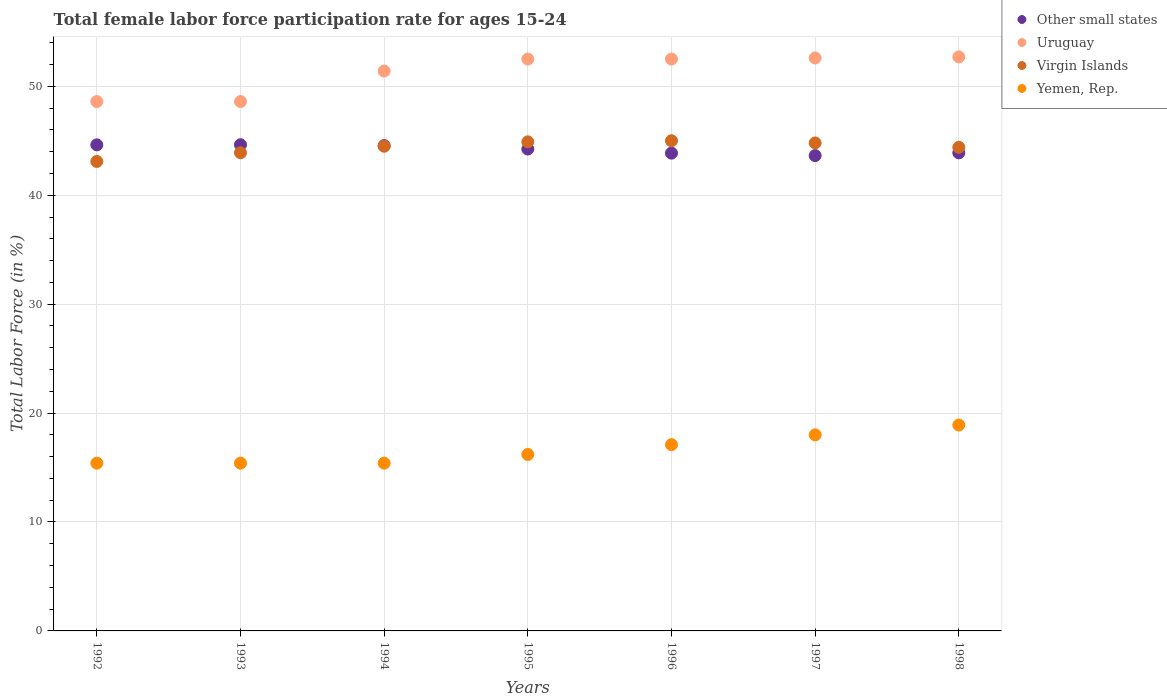How many different coloured dotlines are there?
Provide a short and direct response. 4. What is the female labor force participation rate in Uruguay in 1994?
Your answer should be very brief. 51.4. Across all years, what is the minimum female labor force participation rate in Yemen, Rep.?
Your answer should be compact. 15.4. What is the total female labor force participation rate in Uruguay in the graph?
Your answer should be very brief. 358.9. What is the difference between the female labor force participation rate in Other small states in 1995 and that in 1996?
Your answer should be very brief. 0.38. What is the difference between the female labor force participation rate in Yemen, Rep. in 1997 and the female labor force participation rate in Other small states in 1996?
Provide a succinct answer. -25.86. What is the average female labor force participation rate in Virgin Islands per year?
Provide a succinct answer. 44.37. In the year 1992, what is the difference between the female labor force participation rate in Yemen, Rep. and female labor force participation rate in Virgin Islands?
Make the answer very short. -27.7. What is the ratio of the female labor force participation rate in Uruguay in 1992 to that in 1994?
Provide a succinct answer. 0.95. Is the female labor force participation rate in Other small states in 1994 less than that in 1997?
Your answer should be compact. No. What is the difference between the highest and the second highest female labor force participation rate in Uruguay?
Ensure brevity in your answer.  0.1. What is the difference between the highest and the lowest female labor force participation rate in Yemen, Rep.?
Offer a very short reply. 3.5. How many dotlines are there?
Give a very brief answer. 4. Does the graph contain any zero values?
Your answer should be compact. No. Does the graph contain grids?
Make the answer very short. Yes. Where does the legend appear in the graph?
Offer a very short reply. Top right. What is the title of the graph?
Provide a succinct answer. Total female labor force participation rate for ages 15-24. Does "Honduras" appear as one of the legend labels in the graph?
Make the answer very short. No. What is the label or title of the Y-axis?
Keep it short and to the point. Total Labor Force (in %). What is the Total Labor Force (in %) of Other small states in 1992?
Provide a short and direct response. 44.62. What is the Total Labor Force (in %) in Uruguay in 1992?
Ensure brevity in your answer.  48.6. What is the Total Labor Force (in %) of Virgin Islands in 1992?
Your response must be concise. 43.1. What is the Total Labor Force (in %) of Yemen, Rep. in 1992?
Your response must be concise. 15.4. What is the Total Labor Force (in %) of Other small states in 1993?
Offer a terse response. 44.63. What is the Total Labor Force (in %) in Uruguay in 1993?
Your answer should be very brief. 48.6. What is the Total Labor Force (in %) of Virgin Islands in 1993?
Your answer should be very brief. 43.9. What is the Total Labor Force (in %) in Yemen, Rep. in 1993?
Provide a short and direct response. 15.4. What is the Total Labor Force (in %) of Other small states in 1994?
Your answer should be very brief. 44.55. What is the Total Labor Force (in %) in Uruguay in 1994?
Keep it short and to the point. 51.4. What is the Total Labor Force (in %) in Virgin Islands in 1994?
Provide a short and direct response. 44.5. What is the Total Labor Force (in %) of Yemen, Rep. in 1994?
Your answer should be very brief. 15.4. What is the Total Labor Force (in %) of Other small states in 1995?
Provide a succinct answer. 44.24. What is the Total Labor Force (in %) in Uruguay in 1995?
Provide a succinct answer. 52.5. What is the Total Labor Force (in %) in Virgin Islands in 1995?
Your answer should be very brief. 44.9. What is the Total Labor Force (in %) of Yemen, Rep. in 1995?
Give a very brief answer. 16.2. What is the Total Labor Force (in %) in Other small states in 1996?
Provide a succinct answer. 43.86. What is the Total Labor Force (in %) of Uruguay in 1996?
Provide a short and direct response. 52.5. What is the Total Labor Force (in %) in Virgin Islands in 1996?
Make the answer very short. 45. What is the Total Labor Force (in %) of Yemen, Rep. in 1996?
Your answer should be very brief. 17.1. What is the Total Labor Force (in %) in Other small states in 1997?
Make the answer very short. 43.64. What is the Total Labor Force (in %) of Uruguay in 1997?
Offer a terse response. 52.6. What is the Total Labor Force (in %) in Virgin Islands in 1997?
Make the answer very short. 44.8. What is the Total Labor Force (in %) in Yemen, Rep. in 1997?
Your answer should be compact. 18. What is the Total Labor Force (in %) of Other small states in 1998?
Your response must be concise. 43.89. What is the Total Labor Force (in %) in Uruguay in 1998?
Keep it short and to the point. 52.7. What is the Total Labor Force (in %) of Virgin Islands in 1998?
Your answer should be compact. 44.4. What is the Total Labor Force (in %) of Yemen, Rep. in 1998?
Your answer should be very brief. 18.9. Across all years, what is the maximum Total Labor Force (in %) of Other small states?
Provide a short and direct response. 44.63. Across all years, what is the maximum Total Labor Force (in %) in Uruguay?
Keep it short and to the point. 52.7. Across all years, what is the maximum Total Labor Force (in %) of Yemen, Rep.?
Offer a very short reply. 18.9. Across all years, what is the minimum Total Labor Force (in %) of Other small states?
Keep it short and to the point. 43.64. Across all years, what is the minimum Total Labor Force (in %) in Uruguay?
Keep it short and to the point. 48.6. Across all years, what is the minimum Total Labor Force (in %) in Virgin Islands?
Your answer should be compact. 43.1. Across all years, what is the minimum Total Labor Force (in %) in Yemen, Rep.?
Your response must be concise. 15.4. What is the total Total Labor Force (in %) in Other small states in the graph?
Your answer should be compact. 309.44. What is the total Total Labor Force (in %) in Uruguay in the graph?
Your answer should be compact. 358.9. What is the total Total Labor Force (in %) of Virgin Islands in the graph?
Offer a terse response. 310.6. What is the total Total Labor Force (in %) in Yemen, Rep. in the graph?
Your answer should be compact. 116.4. What is the difference between the Total Labor Force (in %) of Other small states in 1992 and that in 1993?
Your answer should be compact. -0.01. What is the difference between the Total Labor Force (in %) of Uruguay in 1992 and that in 1993?
Keep it short and to the point. 0. What is the difference between the Total Labor Force (in %) of Virgin Islands in 1992 and that in 1993?
Offer a terse response. -0.8. What is the difference between the Total Labor Force (in %) in Other small states in 1992 and that in 1994?
Keep it short and to the point. 0.07. What is the difference between the Total Labor Force (in %) of Uruguay in 1992 and that in 1994?
Your answer should be very brief. -2.8. What is the difference between the Total Labor Force (in %) in Virgin Islands in 1992 and that in 1994?
Provide a succinct answer. -1.4. What is the difference between the Total Labor Force (in %) of Other small states in 1992 and that in 1995?
Keep it short and to the point. 0.39. What is the difference between the Total Labor Force (in %) in Uruguay in 1992 and that in 1995?
Your response must be concise. -3.9. What is the difference between the Total Labor Force (in %) of Other small states in 1992 and that in 1996?
Provide a succinct answer. 0.76. What is the difference between the Total Labor Force (in %) in Uruguay in 1992 and that in 1996?
Ensure brevity in your answer.  -3.9. What is the difference between the Total Labor Force (in %) in Virgin Islands in 1992 and that in 1996?
Ensure brevity in your answer.  -1.9. What is the difference between the Total Labor Force (in %) in Yemen, Rep. in 1992 and that in 1996?
Offer a terse response. -1.7. What is the difference between the Total Labor Force (in %) of Virgin Islands in 1992 and that in 1997?
Your response must be concise. -1.7. What is the difference between the Total Labor Force (in %) in Yemen, Rep. in 1992 and that in 1997?
Offer a terse response. -2.6. What is the difference between the Total Labor Force (in %) in Other small states in 1992 and that in 1998?
Offer a terse response. 0.73. What is the difference between the Total Labor Force (in %) of Virgin Islands in 1992 and that in 1998?
Your answer should be compact. -1.3. What is the difference between the Total Labor Force (in %) of Other small states in 1993 and that in 1994?
Provide a short and direct response. 0.08. What is the difference between the Total Labor Force (in %) of Uruguay in 1993 and that in 1994?
Your response must be concise. -2.8. What is the difference between the Total Labor Force (in %) in Yemen, Rep. in 1993 and that in 1994?
Offer a very short reply. 0. What is the difference between the Total Labor Force (in %) of Other small states in 1993 and that in 1995?
Give a very brief answer. 0.4. What is the difference between the Total Labor Force (in %) in Virgin Islands in 1993 and that in 1995?
Offer a very short reply. -1. What is the difference between the Total Labor Force (in %) of Other small states in 1993 and that in 1996?
Provide a succinct answer. 0.77. What is the difference between the Total Labor Force (in %) of Other small states in 1993 and that in 1997?
Offer a very short reply. 1. What is the difference between the Total Labor Force (in %) in Uruguay in 1993 and that in 1997?
Provide a short and direct response. -4. What is the difference between the Total Labor Force (in %) of Virgin Islands in 1993 and that in 1997?
Ensure brevity in your answer.  -0.9. What is the difference between the Total Labor Force (in %) of Yemen, Rep. in 1993 and that in 1997?
Provide a succinct answer. -2.6. What is the difference between the Total Labor Force (in %) of Other small states in 1993 and that in 1998?
Keep it short and to the point. 0.74. What is the difference between the Total Labor Force (in %) in Virgin Islands in 1993 and that in 1998?
Keep it short and to the point. -0.5. What is the difference between the Total Labor Force (in %) of Other small states in 1994 and that in 1995?
Provide a succinct answer. 0.32. What is the difference between the Total Labor Force (in %) in Uruguay in 1994 and that in 1995?
Provide a short and direct response. -1.1. What is the difference between the Total Labor Force (in %) of Yemen, Rep. in 1994 and that in 1995?
Your answer should be compact. -0.8. What is the difference between the Total Labor Force (in %) of Other small states in 1994 and that in 1996?
Offer a terse response. 0.69. What is the difference between the Total Labor Force (in %) in Virgin Islands in 1994 and that in 1996?
Offer a terse response. -0.5. What is the difference between the Total Labor Force (in %) in Yemen, Rep. in 1994 and that in 1996?
Make the answer very short. -1.7. What is the difference between the Total Labor Force (in %) of Other small states in 1994 and that in 1997?
Your response must be concise. 0.92. What is the difference between the Total Labor Force (in %) in Virgin Islands in 1994 and that in 1997?
Keep it short and to the point. -0.3. What is the difference between the Total Labor Force (in %) in Other small states in 1994 and that in 1998?
Offer a terse response. 0.66. What is the difference between the Total Labor Force (in %) in Virgin Islands in 1994 and that in 1998?
Provide a succinct answer. 0.1. What is the difference between the Total Labor Force (in %) in Yemen, Rep. in 1994 and that in 1998?
Keep it short and to the point. -3.5. What is the difference between the Total Labor Force (in %) of Other small states in 1995 and that in 1996?
Provide a short and direct response. 0.38. What is the difference between the Total Labor Force (in %) of Other small states in 1995 and that in 1997?
Offer a very short reply. 0.6. What is the difference between the Total Labor Force (in %) of Uruguay in 1995 and that in 1997?
Offer a terse response. -0.1. What is the difference between the Total Labor Force (in %) of Virgin Islands in 1995 and that in 1997?
Ensure brevity in your answer.  0.1. What is the difference between the Total Labor Force (in %) of Other small states in 1995 and that in 1998?
Your answer should be very brief. 0.35. What is the difference between the Total Labor Force (in %) of Uruguay in 1995 and that in 1998?
Provide a short and direct response. -0.2. What is the difference between the Total Labor Force (in %) of Virgin Islands in 1995 and that in 1998?
Keep it short and to the point. 0.5. What is the difference between the Total Labor Force (in %) of Yemen, Rep. in 1995 and that in 1998?
Your answer should be very brief. -2.7. What is the difference between the Total Labor Force (in %) in Other small states in 1996 and that in 1997?
Keep it short and to the point. 0.23. What is the difference between the Total Labor Force (in %) in Yemen, Rep. in 1996 and that in 1997?
Your answer should be compact. -0.9. What is the difference between the Total Labor Force (in %) of Other small states in 1996 and that in 1998?
Keep it short and to the point. -0.03. What is the difference between the Total Labor Force (in %) of Uruguay in 1996 and that in 1998?
Give a very brief answer. -0.2. What is the difference between the Total Labor Force (in %) in Virgin Islands in 1996 and that in 1998?
Keep it short and to the point. 0.6. What is the difference between the Total Labor Force (in %) in Yemen, Rep. in 1996 and that in 1998?
Ensure brevity in your answer.  -1.8. What is the difference between the Total Labor Force (in %) of Other small states in 1997 and that in 1998?
Offer a very short reply. -0.25. What is the difference between the Total Labor Force (in %) in Uruguay in 1997 and that in 1998?
Offer a terse response. -0.1. What is the difference between the Total Labor Force (in %) in Yemen, Rep. in 1997 and that in 1998?
Your answer should be very brief. -0.9. What is the difference between the Total Labor Force (in %) in Other small states in 1992 and the Total Labor Force (in %) in Uruguay in 1993?
Your answer should be very brief. -3.98. What is the difference between the Total Labor Force (in %) in Other small states in 1992 and the Total Labor Force (in %) in Virgin Islands in 1993?
Provide a short and direct response. 0.72. What is the difference between the Total Labor Force (in %) of Other small states in 1992 and the Total Labor Force (in %) of Yemen, Rep. in 1993?
Offer a very short reply. 29.22. What is the difference between the Total Labor Force (in %) of Uruguay in 1992 and the Total Labor Force (in %) of Yemen, Rep. in 1993?
Ensure brevity in your answer.  33.2. What is the difference between the Total Labor Force (in %) of Virgin Islands in 1992 and the Total Labor Force (in %) of Yemen, Rep. in 1993?
Your answer should be compact. 27.7. What is the difference between the Total Labor Force (in %) in Other small states in 1992 and the Total Labor Force (in %) in Uruguay in 1994?
Your response must be concise. -6.78. What is the difference between the Total Labor Force (in %) of Other small states in 1992 and the Total Labor Force (in %) of Virgin Islands in 1994?
Keep it short and to the point. 0.12. What is the difference between the Total Labor Force (in %) of Other small states in 1992 and the Total Labor Force (in %) of Yemen, Rep. in 1994?
Offer a terse response. 29.22. What is the difference between the Total Labor Force (in %) of Uruguay in 1992 and the Total Labor Force (in %) of Yemen, Rep. in 1994?
Provide a short and direct response. 33.2. What is the difference between the Total Labor Force (in %) in Virgin Islands in 1992 and the Total Labor Force (in %) in Yemen, Rep. in 1994?
Keep it short and to the point. 27.7. What is the difference between the Total Labor Force (in %) of Other small states in 1992 and the Total Labor Force (in %) of Uruguay in 1995?
Provide a succinct answer. -7.88. What is the difference between the Total Labor Force (in %) of Other small states in 1992 and the Total Labor Force (in %) of Virgin Islands in 1995?
Make the answer very short. -0.28. What is the difference between the Total Labor Force (in %) in Other small states in 1992 and the Total Labor Force (in %) in Yemen, Rep. in 1995?
Your answer should be compact. 28.42. What is the difference between the Total Labor Force (in %) of Uruguay in 1992 and the Total Labor Force (in %) of Virgin Islands in 1995?
Provide a short and direct response. 3.7. What is the difference between the Total Labor Force (in %) of Uruguay in 1992 and the Total Labor Force (in %) of Yemen, Rep. in 1995?
Your answer should be very brief. 32.4. What is the difference between the Total Labor Force (in %) in Virgin Islands in 1992 and the Total Labor Force (in %) in Yemen, Rep. in 1995?
Offer a terse response. 26.9. What is the difference between the Total Labor Force (in %) in Other small states in 1992 and the Total Labor Force (in %) in Uruguay in 1996?
Ensure brevity in your answer.  -7.88. What is the difference between the Total Labor Force (in %) in Other small states in 1992 and the Total Labor Force (in %) in Virgin Islands in 1996?
Your answer should be compact. -0.38. What is the difference between the Total Labor Force (in %) of Other small states in 1992 and the Total Labor Force (in %) of Yemen, Rep. in 1996?
Make the answer very short. 27.52. What is the difference between the Total Labor Force (in %) in Uruguay in 1992 and the Total Labor Force (in %) in Yemen, Rep. in 1996?
Offer a very short reply. 31.5. What is the difference between the Total Labor Force (in %) of Virgin Islands in 1992 and the Total Labor Force (in %) of Yemen, Rep. in 1996?
Your answer should be compact. 26. What is the difference between the Total Labor Force (in %) of Other small states in 1992 and the Total Labor Force (in %) of Uruguay in 1997?
Offer a terse response. -7.98. What is the difference between the Total Labor Force (in %) of Other small states in 1992 and the Total Labor Force (in %) of Virgin Islands in 1997?
Provide a succinct answer. -0.18. What is the difference between the Total Labor Force (in %) of Other small states in 1992 and the Total Labor Force (in %) of Yemen, Rep. in 1997?
Make the answer very short. 26.62. What is the difference between the Total Labor Force (in %) of Uruguay in 1992 and the Total Labor Force (in %) of Yemen, Rep. in 1997?
Make the answer very short. 30.6. What is the difference between the Total Labor Force (in %) in Virgin Islands in 1992 and the Total Labor Force (in %) in Yemen, Rep. in 1997?
Your answer should be very brief. 25.1. What is the difference between the Total Labor Force (in %) in Other small states in 1992 and the Total Labor Force (in %) in Uruguay in 1998?
Make the answer very short. -8.08. What is the difference between the Total Labor Force (in %) of Other small states in 1992 and the Total Labor Force (in %) of Virgin Islands in 1998?
Make the answer very short. 0.22. What is the difference between the Total Labor Force (in %) in Other small states in 1992 and the Total Labor Force (in %) in Yemen, Rep. in 1998?
Make the answer very short. 25.72. What is the difference between the Total Labor Force (in %) of Uruguay in 1992 and the Total Labor Force (in %) of Yemen, Rep. in 1998?
Give a very brief answer. 29.7. What is the difference between the Total Labor Force (in %) of Virgin Islands in 1992 and the Total Labor Force (in %) of Yemen, Rep. in 1998?
Provide a short and direct response. 24.2. What is the difference between the Total Labor Force (in %) of Other small states in 1993 and the Total Labor Force (in %) of Uruguay in 1994?
Your answer should be compact. -6.77. What is the difference between the Total Labor Force (in %) of Other small states in 1993 and the Total Labor Force (in %) of Virgin Islands in 1994?
Keep it short and to the point. 0.13. What is the difference between the Total Labor Force (in %) in Other small states in 1993 and the Total Labor Force (in %) in Yemen, Rep. in 1994?
Provide a short and direct response. 29.23. What is the difference between the Total Labor Force (in %) of Uruguay in 1993 and the Total Labor Force (in %) of Yemen, Rep. in 1994?
Keep it short and to the point. 33.2. What is the difference between the Total Labor Force (in %) of Virgin Islands in 1993 and the Total Labor Force (in %) of Yemen, Rep. in 1994?
Your answer should be compact. 28.5. What is the difference between the Total Labor Force (in %) of Other small states in 1993 and the Total Labor Force (in %) of Uruguay in 1995?
Make the answer very short. -7.87. What is the difference between the Total Labor Force (in %) of Other small states in 1993 and the Total Labor Force (in %) of Virgin Islands in 1995?
Ensure brevity in your answer.  -0.27. What is the difference between the Total Labor Force (in %) of Other small states in 1993 and the Total Labor Force (in %) of Yemen, Rep. in 1995?
Ensure brevity in your answer.  28.43. What is the difference between the Total Labor Force (in %) of Uruguay in 1993 and the Total Labor Force (in %) of Virgin Islands in 1995?
Your answer should be very brief. 3.7. What is the difference between the Total Labor Force (in %) in Uruguay in 1993 and the Total Labor Force (in %) in Yemen, Rep. in 1995?
Provide a short and direct response. 32.4. What is the difference between the Total Labor Force (in %) in Virgin Islands in 1993 and the Total Labor Force (in %) in Yemen, Rep. in 1995?
Offer a terse response. 27.7. What is the difference between the Total Labor Force (in %) of Other small states in 1993 and the Total Labor Force (in %) of Uruguay in 1996?
Your answer should be compact. -7.87. What is the difference between the Total Labor Force (in %) in Other small states in 1993 and the Total Labor Force (in %) in Virgin Islands in 1996?
Your response must be concise. -0.37. What is the difference between the Total Labor Force (in %) in Other small states in 1993 and the Total Labor Force (in %) in Yemen, Rep. in 1996?
Provide a short and direct response. 27.53. What is the difference between the Total Labor Force (in %) in Uruguay in 1993 and the Total Labor Force (in %) in Yemen, Rep. in 1996?
Offer a terse response. 31.5. What is the difference between the Total Labor Force (in %) of Virgin Islands in 1993 and the Total Labor Force (in %) of Yemen, Rep. in 1996?
Give a very brief answer. 26.8. What is the difference between the Total Labor Force (in %) in Other small states in 1993 and the Total Labor Force (in %) in Uruguay in 1997?
Provide a succinct answer. -7.97. What is the difference between the Total Labor Force (in %) of Other small states in 1993 and the Total Labor Force (in %) of Virgin Islands in 1997?
Provide a succinct answer. -0.17. What is the difference between the Total Labor Force (in %) in Other small states in 1993 and the Total Labor Force (in %) in Yemen, Rep. in 1997?
Give a very brief answer. 26.63. What is the difference between the Total Labor Force (in %) of Uruguay in 1993 and the Total Labor Force (in %) of Yemen, Rep. in 1997?
Provide a succinct answer. 30.6. What is the difference between the Total Labor Force (in %) in Virgin Islands in 1993 and the Total Labor Force (in %) in Yemen, Rep. in 1997?
Your response must be concise. 25.9. What is the difference between the Total Labor Force (in %) in Other small states in 1993 and the Total Labor Force (in %) in Uruguay in 1998?
Provide a succinct answer. -8.07. What is the difference between the Total Labor Force (in %) of Other small states in 1993 and the Total Labor Force (in %) of Virgin Islands in 1998?
Provide a short and direct response. 0.23. What is the difference between the Total Labor Force (in %) in Other small states in 1993 and the Total Labor Force (in %) in Yemen, Rep. in 1998?
Offer a very short reply. 25.73. What is the difference between the Total Labor Force (in %) in Uruguay in 1993 and the Total Labor Force (in %) in Yemen, Rep. in 1998?
Your response must be concise. 29.7. What is the difference between the Total Labor Force (in %) in Other small states in 1994 and the Total Labor Force (in %) in Uruguay in 1995?
Your response must be concise. -7.95. What is the difference between the Total Labor Force (in %) of Other small states in 1994 and the Total Labor Force (in %) of Virgin Islands in 1995?
Provide a short and direct response. -0.35. What is the difference between the Total Labor Force (in %) of Other small states in 1994 and the Total Labor Force (in %) of Yemen, Rep. in 1995?
Offer a very short reply. 28.35. What is the difference between the Total Labor Force (in %) of Uruguay in 1994 and the Total Labor Force (in %) of Yemen, Rep. in 1995?
Your response must be concise. 35.2. What is the difference between the Total Labor Force (in %) of Virgin Islands in 1994 and the Total Labor Force (in %) of Yemen, Rep. in 1995?
Offer a very short reply. 28.3. What is the difference between the Total Labor Force (in %) of Other small states in 1994 and the Total Labor Force (in %) of Uruguay in 1996?
Your response must be concise. -7.95. What is the difference between the Total Labor Force (in %) of Other small states in 1994 and the Total Labor Force (in %) of Virgin Islands in 1996?
Your response must be concise. -0.45. What is the difference between the Total Labor Force (in %) of Other small states in 1994 and the Total Labor Force (in %) of Yemen, Rep. in 1996?
Make the answer very short. 27.45. What is the difference between the Total Labor Force (in %) in Uruguay in 1994 and the Total Labor Force (in %) in Virgin Islands in 1996?
Make the answer very short. 6.4. What is the difference between the Total Labor Force (in %) in Uruguay in 1994 and the Total Labor Force (in %) in Yemen, Rep. in 1996?
Give a very brief answer. 34.3. What is the difference between the Total Labor Force (in %) of Virgin Islands in 1994 and the Total Labor Force (in %) of Yemen, Rep. in 1996?
Your response must be concise. 27.4. What is the difference between the Total Labor Force (in %) of Other small states in 1994 and the Total Labor Force (in %) of Uruguay in 1997?
Offer a terse response. -8.05. What is the difference between the Total Labor Force (in %) of Other small states in 1994 and the Total Labor Force (in %) of Virgin Islands in 1997?
Your answer should be compact. -0.25. What is the difference between the Total Labor Force (in %) of Other small states in 1994 and the Total Labor Force (in %) of Yemen, Rep. in 1997?
Your response must be concise. 26.55. What is the difference between the Total Labor Force (in %) in Uruguay in 1994 and the Total Labor Force (in %) in Yemen, Rep. in 1997?
Your response must be concise. 33.4. What is the difference between the Total Labor Force (in %) in Other small states in 1994 and the Total Labor Force (in %) in Uruguay in 1998?
Your response must be concise. -8.15. What is the difference between the Total Labor Force (in %) in Other small states in 1994 and the Total Labor Force (in %) in Virgin Islands in 1998?
Your response must be concise. 0.15. What is the difference between the Total Labor Force (in %) of Other small states in 1994 and the Total Labor Force (in %) of Yemen, Rep. in 1998?
Give a very brief answer. 25.65. What is the difference between the Total Labor Force (in %) in Uruguay in 1994 and the Total Labor Force (in %) in Virgin Islands in 1998?
Give a very brief answer. 7. What is the difference between the Total Labor Force (in %) of Uruguay in 1994 and the Total Labor Force (in %) of Yemen, Rep. in 1998?
Your answer should be compact. 32.5. What is the difference between the Total Labor Force (in %) in Virgin Islands in 1994 and the Total Labor Force (in %) in Yemen, Rep. in 1998?
Your response must be concise. 25.6. What is the difference between the Total Labor Force (in %) of Other small states in 1995 and the Total Labor Force (in %) of Uruguay in 1996?
Ensure brevity in your answer.  -8.26. What is the difference between the Total Labor Force (in %) in Other small states in 1995 and the Total Labor Force (in %) in Virgin Islands in 1996?
Ensure brevity in your answer.  -0.76. What is the difference between the Total Labor Force (in %) of Other small states in 1995 and the Total Labor Force (in %) of Yemen, Rep. in 1996?
Make the answer very short. 27.14. What is the difference between the Total Labor Force (in %) in Uruguay in 1995 and the Total Labor Force (in %) in Virgin Islands in 1996?
Keep it short and to the point. 7.5. What is the difference between the Total Labor Force (in %) of Uruguay in 1995 and the Total Labor Force (in %) of Yemen, Rep. in 1996?
Keep it short and to the point. 35.4. What is the difference between the Total Labor Force (in %) in Virgin Islands in 1995 and the Total Labor Force (in %) in Yemen, Rep. in 1996?
Your answer should be very brief. 27.8. What is the difference between the Total Labor Force (in %) of Other small states in 1995 and the Total Labor Force (in %) of Uruguay in 1997?
Your answer should be very brief. -8.36. What is the difference between the Total Labor Force (in %) of Other small states in 1995 and the Total Labor Force (in %) of Virgin Islands in 1997?
Provide a short and direct response. -0.56. What is the difference between the Total Labor Force (in %) of Other small states in 1995 and the Total Labor Force (in %) of Yemen, Rep. in 1997?
Your answer should be very brief. 26.24. What is the difference between the Total Labor Force (in %) in Uruguay in 1995 and the Total Labor Force (in %) in Virgin Islands in 1997?
Your answer should be compact. 7.7. What is the difference between the Total Labor Force (in %) of Uruguay in 1995 and the Total Labor Force (in %) of Yemen, Rep. in 1997?
Ensure brevity in your answer.  34.5. What is the difference between the Total Labor Force (in %) in Virgin Islands in 1995 and the Total Labor Force (in %) in Yemen, Rep. in 1997?
Your answer should be very brief. 26.9. What is the difference between the Total Labor Force (in %) in Other small states in 1995 and the Total Labor Force (in %) in Uruguay in 1998?
Provide a short and direct response. -8.46. What is the difference between the Total Labor Force (in %) in Other small states in 1995 and the Total Labor Force (in %) in Virgin Islands in 1998?
Make the answer very short. -0.16. What is the difference between the Total Labor Force (in %) in Other small states in 1995 and the Total Labor Force (in %) in Yemen, Rep. in 1998?
Keep it short and to the point. 25.34. What is the difference between the Total Labor Force (in %) of Uruguay in 1995 and the Total Labor Force (in %) of Virgin Islands in 1998?
Offer a very short reply. 8.1. What is the difference between the Total Labor Force (in %) in Uruguay in 1995 and the Total Labor Force (in %) in Yemen, Rep. in 1998?
Give a very brief answer. 33.6. What is the difference between the Total Labor Force (in %) in Virgin Islands in 1995 and the Total Labor Force (in %) in Yemen, Rep. in 1998?
Your answer should be very brief. 26. What is the difference between the Total Labor Force (in %) in Other small states in 1996 and the Total Labor Force (in %) in Uruguay in 1997?
Ensure brevity in your answer.  -8.74. What is the difference between the Total Labor Force (in %) in Other small states in 1996 and the Total Labor Force (in %) in Virgin Islands in 1997?
Give a very brief answer. -0.94. What is the difference between the Total Labor Force (in %) in Other small states in 1996 and the Total Labor Force (in %) in Yemen, Rep. in 1997?
Offer a very short reply. 25.86. What is the difference between the Total Labor Force (in %) in Uruguay in 1996 and the Total Labor Force (in %) in Virgin Islands in 1997?
Keep it short and to the point. 7.7. What is the difference between the Total Labor Force (in %) of Uruguay in 1996 and the Total Labor Force (in %) of Yemen, Rep. in 1997?
Ensure brevity in your answer.  34.5. What is the difference between the Total Labor Force (in %) of Virgin Islands in 1996 and the Total Labor Force (in %) of Yemen, Rep. in 1997?
Your response must be concise. 27. What is the difference between the Total Labor Force (in %) of Other small states in 1996 and the Total Labor Force (in %) of Uruguay in 1998?
Offer a terse response. -8.84. What is the difference between the Total Labor Force (in %) in Other small states in 1996 and the Total Labor Force (in %) in Virgin Islands in 1998?
Keep it short and to the point. -0.54. What is the difference between the Total Labor Force (in %) of Other small states in 1996 and the Total Labor Force (in %) of Yemen, Rep. in 1998?
Give a very brief answer. 24.96. What is the difference between the Total Labor Force (in %) in Uruguay in 1996 and the Total Labor Force (in %) in Virgin Islands in 1998?
Ensure brevity in your answer.  8.1. What is the difference between the Total Labor Force (in %) in Uruguay in 1996 and the Total Labor Force (in %) in Yemen, Rep. in 1998?
Offer a very short reply. 33.6. What is the difference between the Total Labor Force (in %) of Virgin Islands in 1996 and the Total Labor Force (in %) of Yemen, Rep. in 1998?
Offer a terse response. 26.1. What is the difference between the Total Labor Force (in %) in Other small states in 1997 and the Total Labor Force (in %) in Uruguay in 1998?
Keep it short and to the point. -9.06. What is the difference between the Total Labor Force (in %) in Other small states in 1997 and the Total Labor Force (in %) in Virgin Islands in 1998?
Keep it short and to the point. -0.76. What is the difference between the Total Labor Force (in %) in Other small states in 1997 and the Total Labor Force (in %) in Yemen, Rep. in 1998?
Your response must be concise. 24.74. What is the difference between the Total Labor Force (in %) of Uruguay in 1997 and the Total Labor Force (in %) of Yemen, Rep. in 1998?
Keep it short and to the point. 33.7. What is the difference between the Total Labor Force (in %) of Virgin Islands in 1997 and the Total Labor Force (in %) of Yemen, Rep. in 1998?
Keep it short and to the point. 25.9. What is the average Total Labor Force (in %) of Other small states per year?
Your response must be concise. 44.21. What is the average Total Labor Force (in %) of Uruguay per year?
Your answer should be very brief. 51.27. What is the average Total Labor Force (in %) of Virgin Islands per year?
Offer a terse response. 44.37. What is the average Total Labor Force (in %) of Yemen, Rep. per year?
Make the answer very short. 16.63. In the year 1992, what is the difference between the Total Labor Force (in %) of Other small states and Total Labor Force (in %) of Uruguay?
Your response must be concise. -3.98. In the year 1992, what is the difference between the Total Labor Force (in %) of Other small states and Total Labor Force (in %) of Virgin Islands?
Offer a very short reply. 1.52. In the year 1992, what is the difference between the Total Labor Force (in %) in Other small states and Total Labor Force (in %) in Yemen, Rep.?
Offer a very short reply. 29.22. In the year 1992, what is the difference between the Total Labor Force (in %) of Uruguay and Total Labor Force (in %) of Virgin Islands?
Your answer should be compact. 5.5. In the year 1992, what is the difference between the Total Labor Force (in %) of Uruguay and Total Labor Force (in %) of Yemen, Rep.?
Your response must be concise. 33.2. In the year 1992, what is the difference between the Total Labor Force (in %) of Virgin Islands and Total Labor Force (in %) of Yemen, Rep.?
Offer a very short reply. 27.7. In the year 1993, what is the difference between the Total Labor Force (in %) of Other small states and Total Labor Force (in %) of Uruguay?
Offer a terse response. -3.97. In the year 1993, what is the difference between the Total Labor Force (in %) of Other small states and Total Labor Force (in %) of Virgin Islands?
Provide a short and direct response. 0.73. In the year 1993, what is the difference between the Total Labor Force (in %) in Other small states and Total Labor Force (in %) in Yemen, Rep.?
Offer a terse response. 29.23. In the year 1993, what is the difference between the Total Labor Force (in %) in Uruguay and Total Labor Force (in %) in Yemen, Rep.?
Your answer should be compact. 33.2. In the year 1994, what is the difference between the Total Labor Force (in %) in Other small states and Total Labor Force (in %) in Uruguay?
Give a very brief answer. -6.85. In the year 1994, what is the difference between the Total Labor Force (in %) of Other small states and Total Labor Force (in %) of Virgin Islands?
Offer a terse response. 0.05. In the year 1994, what is the difference between the Total Labor Force (in %) in Other small states and Total Labor Force (in %) in Yemen, Rep.?
Your response must be concise. 29.15. In the year 1994, what is the difference between the Total Labor Force (in %) of Virgin Islands and Total Labor Force (in %) of Yemen, Rep.?
Offer a very short reply. 29.1. In the year 1995, what is the difference between the Total Labor Force (in %) of Other small states and Total Labor Force (in %) of Uruguay?
Make the answer very short. -8.26. In the year 1995, what is the difference between the Total Labor Force (in %) of Other small states and Total Labor Force (in %) of Virgin Islands?
Your answer should be compact. -0.66. In the year 1995, what is the difference between the Total Labor Force (in %) of Other small states and Total Labor Force (in %) of Yemen, Rep.?
Offer a terse response. 28.04. In the year 1995, what is the difference between the Total Labor Force (in %) in Uruguay and Total Labor Force (in %) in Virgin Islands?
Your answer should be very brief. 7.6. In the year 1995, what is the difference between the Total Labor Force (in %) of Uruguay and Total Labor Force (in %) of Yemen, Rep.?
Make the answer very short. 36.3. In the year 1995, what is the difference between the Total Labor Force (in %) in Virgin Islands and Total Labor Force (in %) in Yemen, Rep.?
Provide a short and direct response. 28.7. In the year 1996, what is the difference between the Total Labor Force (in %) in Other small states and Total Labor Force (in %) in Uruguay?
Ensure brevity in your answer.  -8.64. In the year 1996, what is the difference between the Total Labor Force (in %) in Other small states and Total Labor Force (in %) in Virgin Islands?
Make the answer very short. -1.14. In the year 1996, what is the difference between the Total Labor Force (in %) in Other small states and Total Labor Force (in %) in Yemen, Rep.?
Your answer should be compact. 26.76. In the year 1996, what is the difference between the Total Labor Force (in %) of Uruguay and Total Labor Force (in %) of Virgin Islands?
Provide a short and direct response. 7.5. In the year 1996, what is the difference between the Total Labor Force (in %) in Uruguay and Total Labor Force (in %) in Yemen, Rep.?
Your response must be concise. 35.4. In the year 1996, what is the difference between the Total Labor Force (in %) in Virgin Islands and Total Labor Force (in %) in Yemen, Rep.?
Ensure brevity in your answer.  27.9. In the year 1997, what is the difference between the Total Labor Force (in %) in Other small states and Total Labor Force (in %) in Uruguay?
Provide a short and direct response. -8.96. In the year 1997, what is the difference between the Total Labor Force (in %) in Other small states and Total Labor Force (in %) in Virgin Islands?
Your answer should be compact. -1.16. In the year 1997, what is the difference between the Total Labor Force (in %) of Other small states and Total Labor Force (in %) of Yemen, Rep.?
Your answer should be compact. 25.64. In the year 1997, what is the difference between the Total Labor Force (in %) of Uruguay and Total Labor Force (in %) of Yemen, Rep.?
Provide a succinct answer. 34.6. In the year 1997, what is the difference between the Total Labor Force (in %) in Virgin Islands and Total Labor Force (in %) in Yemen, Rep.?
Make the answer very short. 26.8. In the year 1998, what is the difference between the Total Labor Force (in %) in Other small states and Total Labor Force (in %) in Uruguay?
Ensure brevity in your answer.  -8.81. In the year 1998, what is the difference between the Total Labor Force (in %) in Other small states and Total Labor Force (in %) in Virgin Islands?
Provide a short and direct response. -0.51. In the year 1998, what is the difference between the Total Labor Force (in %) of Other small states and Total Labor Force (in %) of Yemen, Rep.?
Ensure brevity in your answer.  24.99. In the year 1998, what is the difference between the Total Labor Force (in %) in Uruguay and Total Labor Force (in %) in Yemen, Rep.?
Ensure brevity in your answer.  33.8. In the year 1998, what is the difference between the Total Labor Force (in %) in Virgin Islands and Total Labor Force (in %) in Yemen, Rep.?
Ensure brevity in your answer.  25.5. What is the ratio of the Total Labor Force (in %) of Other small states in 1992 to that in 1993?
Offer a terse response. 1. What is the ratio of the Total Labor Force (in %) of Uruguay in 1992 to that in 1993?
Provide a short and direct response. 1. What is the ratio of the Total Labor Force (in %) of Virgin Islands in 1992 to that in 1993?
Offer a terse response. 0.98. What is the ratio of the Total Labor Force (in %) in Other small states in 1992 to that in 1994?
Give a very brief answer. 1. What is the ratio of the Total Labor Force (in %) of Uruguay in 1992 to that in 1994?
Your answer should be compact. 0.95. What is the ratio of the Total Labor Force (in %) in Virgin Islands in 1992 to that in 1994?
Offer a terse response. 0.97. What is the ratio of the Total Labor Force (in %) in Yemen, Rep. in 1992 to that in 1994?
Offer a terse response. 1. What is the ratio of the Total Labor Force (in %) of Other small states in 1992 to that in 1995?
Provide a short and direct response. 1.01. What is the ratio of the Total Labor Force (in %) in Uruguay in 1992 to that in 1995?
Provide a succinct answer. 0.93. What is the ratio of the Total Labor Force (in %) in Virgin Islands in 1992 to that in 1995?
Offer a terse response. 0.96. What is the ratio of the Total Labor Force (in %) of Yemen, Rep. in 1992 to that in 1995?
Offer a very short reply. 0.95. What is the ratio of the Total Labor Force (in %) in Other small states in 1992 to that in 1996?
Provide a succinct answer. 1.02. What is the ratio of the Total Labor Force (in %) of Uruguay in 1992 to that in 1996?
Give a very brief answer. 0.93. What is the ratio of the Total Labor Force (in %) in Virgin Islands in 1992 to that in 1996?
Your answer should be very brief. 0.96. What is the ratio of the Total Labor Force (in %) in Yemen, Rep. in 1992 to that in 1996?
Your answer should be very brief. 0.9. What is the ratio of the Total Labor Force (in %) in Other small states in 1992 to that in 1997?
Your answer should be very brief. 1.02. What is the ratio of the Total Labor Force (in %) in Uruguay in 1992 to that in 1997?
Provide a short and direct response. 0.92. What is the ratio of the Total Labor Force (in %) of Virgin Islands in 1992 to that in 1997?
Your answer should be very brief. 0.96. What is the ratio of the Total Labor Force (in %) in Yemen, Rep. in 1992 to that in 1997?
Your response must be concise. 0.86. What is the ratio of the Total Labor Force (in %) in Other small states in 1992 to that in 1998?
Your answer should be compact. 1.02. What is the ratio of the Total Labor Force (in %) of Uruguay in 1992 to that in 1998?
Your answer should be compact. 0.92. What is the ratio of the Total Labor Force (in %) in Virgin Islands in 1992 to that in 1998?
Keep it short and to the point. 0.97. What is the ratio of the Total Labor Force (in %) in Yemen, Rep. in 1992 to that in 1998?
Your response must be concise. 0.81. What is the ratio of the Total Labor Force (in %) in Other small states in 1993 to that in 1994?
Offer a very short reply. 1. What is the ratio of the Total Labor Force (in %) in Uruguay in 1993 to that in 1994?
Keep it short and to the point. 0.95. What is the ratio of the Total Labor Force (in %) in Virgin Islands in 1993 to that in 1994?
Your answer should be very brief. 0.99. What is the ratio of the Total Labor Force (in %) of Yemen, Rep. in 1993 to that in 1994?
Give a very brief answer. 1. What is the ratio of the Total Labor Force (in %) in Uruguay in 1993 to that in 1995?
Offer a very short reply. 0.93. What is the ratio of the Total Labor Force (in %) of Virgin Islands in 1993 to that in 1995?
Your answer should be compact. 0.98. What is the ratio of the Total Labor Force (in %) in Yemen, Rep. in 1993 to that in 1995?
Give a very brief answer. 0.95. What is the ratio of the Total Labor Force (in %) of Other small states in 1993 to that in 1996?
Keep it short and to the point. 1.02. What is the ratio of the Total Labor Force (in %) of Uruguay in 1993 to that in 1996?
Your response must be concise. 0.93. What is the ratio of the Total Labor Force (in %) in Virgin Islands in 1993 to that in 1996?
Offer a very short reply. 0.98. What is the ratio of the Total Labor Force (in %) of Yemen, Rep. in 1993 to that in 1996?
Provide a short and direct response. 0.9. What is the ratio of the Total Labor Force (in %) of Other small states in 1993 to that in 1997?
Ensure brevity in your answer.  1.02. What is the ratio of the Total Labor Force (in %) of Uruguay in 1993 to that in 1997?
Provide a succinct answer. 0.92. What is the ratio of the Total Labor Force (in %) in Virgin Islands in 1993 to that in 1997?
Your answer should be compact. 0.98. What is the ratio of the Total Labor Force (in %) in Yemen, Rep. in 1993 to that in 1997?
Offer a very short reply. 0.86. What is the ratio of the Total Labor Force (in %) in Uruguay in 1993 to that in 1998?
Provide a succinct answer. 0.92. What is the ratio of the Total Labor Force (in %) of Virgin Islands in 1993 to that in 1998?
Your answer should be compact. 0.99. What is the ratio of the Total Labor Force (in %) in Yemen, Rep. in 1993 to that in 1998?
Your answer should be compact. 0.81. What is the ratio of the Total Labor Force (in %) of Uruguay in 1994 to that in 1995?
Give a very brief answer. 0.98. What is the ratio of the Total Labor Force (in %) in Yemen, Rep. in 1994 to that in 1995?
Your answer should be compact. 0.95. What is the ratio of the Total Labor Force (in %) of Other small states in 1994 to that in 1996?
Offer a terse response. 1.02. What is the ratio of the Total Labor Force (in %) of Uruguay in 1994 to that in 1996?
Offer a very short reply. 0.98. What is the ratio of the Total Labor Force (in %) in Virgin Islands in 1994 to that in 1996?
Ensure brevity in your answer.  0.99. What is the ratio of the Total Labor Force (in %) in Yemen, Rep. in 1994 to that in 1996?
Your answer should be compact. 0.9. What is the ratio of the Total Labor Force (in %) in Other small states in 1994 to that in 1997?
Offer a terse response. 1.02. What is the ratio of the Total Labor Force (in %) of Uruguay in 1994 to that in 1997?
Offer a terse response. 0.98. What is the ratio of the Total Labor Force (in %) in Virgin Islands in 1994 to that in 1997?
Make the answer very short. 0.99. What is the ratio of the Total Labor Force (in %) in Yemen, Rep. in 1994 to that in 1997?
Your answer should be compact. 0.86. What is the ratio of the Total Labor Force (in %) of Other small states in 1994 to that in 1998?
Give a very brief answer. 1.02. What is the ratio of the Total Labor Force (in %) in Uruguay in 1994 to that in 1998?
Offer a terse response. 0.98. What is the ratio of the Total Labor Force (in %) in Virgin Islands in 1994 to that in 1998?
Give a very brief answer. 1. What is the ratio of the Total Labor Force (in %) of Yemen, Rep. in 1994 to that in 1998?
Provide a succinct answer. 0.81. What is the ratio of the Total Labor Force (in %) in Other small states in 1995 to that in 1996?
Ensure brevity in your answer.  1.01. What is the ratio of the Total Labor Force (in %) in Uruguay in 1995 to that in 1996?
Offer a very short reply. 1. What is the ratio of the Total Labor Force (in %) of Virgin Islands in 1995 to that in 1996?
Your answer should be compact. 1. What is the ratio of the Total Labor Force (in %) in Other small states in 1995 to that in 1997?
Your response must be concise. 1.01. What is the ratio of the Total Labor Force (in %) of Uruguay in 1995 to that in 1997?
Your answer should be very brief. 1. What is the ratio of the Total Labor Force (in %) in Yemen, Rep. in 1995 to that in 1997?
Your answer should be compact. 0.9. What is the ratio of the Total Labor Force (in %) in Other small states in 1995 to that in 1998?
Give a very brief answer. 1.01. What is the ratio of the Total Labor Force (in %) of Uruguay in 1995 to that in 1998?
Your answer should be compact. 1. What is the ratio of the Total Labor Force (in %) of Virgin Islands in 1995 to that in 1998?
Provide a short and direct response. 1.01. What is the ratio of the Total Labor Force (in %) in Virgin Islands in 1996 to that in 1997?
Your response must be concise. 1. What is the ratio of the Total Labor Force (in %) in Virgin Islands in 1996 to that in 1998?
Give a very brief answer. 1.01. What is the ratio of the Total Labor Force (in %) in Yemen, Rep. in 1996 to that in 1998?
Give a very brief answer. 0.9. What is the ratio of the Total Labor Force (in %) in Other small states in 1997 to that in 1998?
Offer a very short reply. 0.99. What is the ratio of the Total Labor Force (in %) of Uruguay in 1997 to that in 1998?
Provide a short and direct response. 1. What is the ratio of the Total Labor Force (in %) of Virgin Islands in 1997 to that in 1998?
Offer a very short reply. 1.01. What is the difference between the highest and the second highest Total Labor Force (in %) of Other small states?
Provide a short and direct response. 0.01. What is the difference between the highest and the second highest Total Labor Force (in %) in Yemen, Rep.?
Give a very brief answer. 0.9. What is the difference between the highest and the lowest Total Labor Force (in %) in Yemen, Rep.?
Your response must be concise. 3.5. 